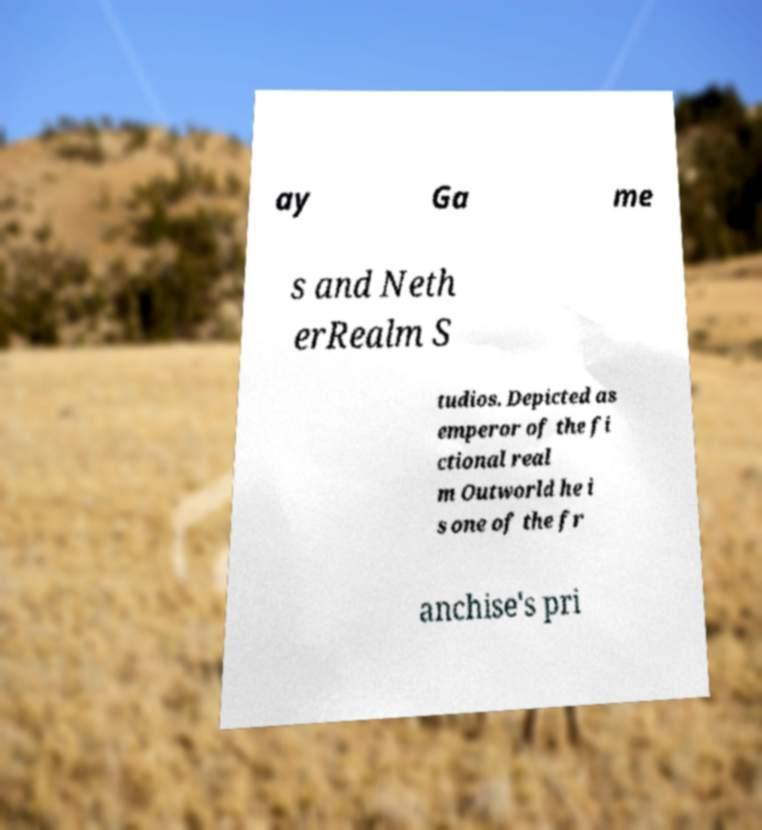What messages or text are displayed in this image? I need them in a readable, typed format. ay Ga me s and Neth erRealm S tudios. Depicted as emperor of the fi ctional real m Outworld he i s one of the fr anchise's pri 